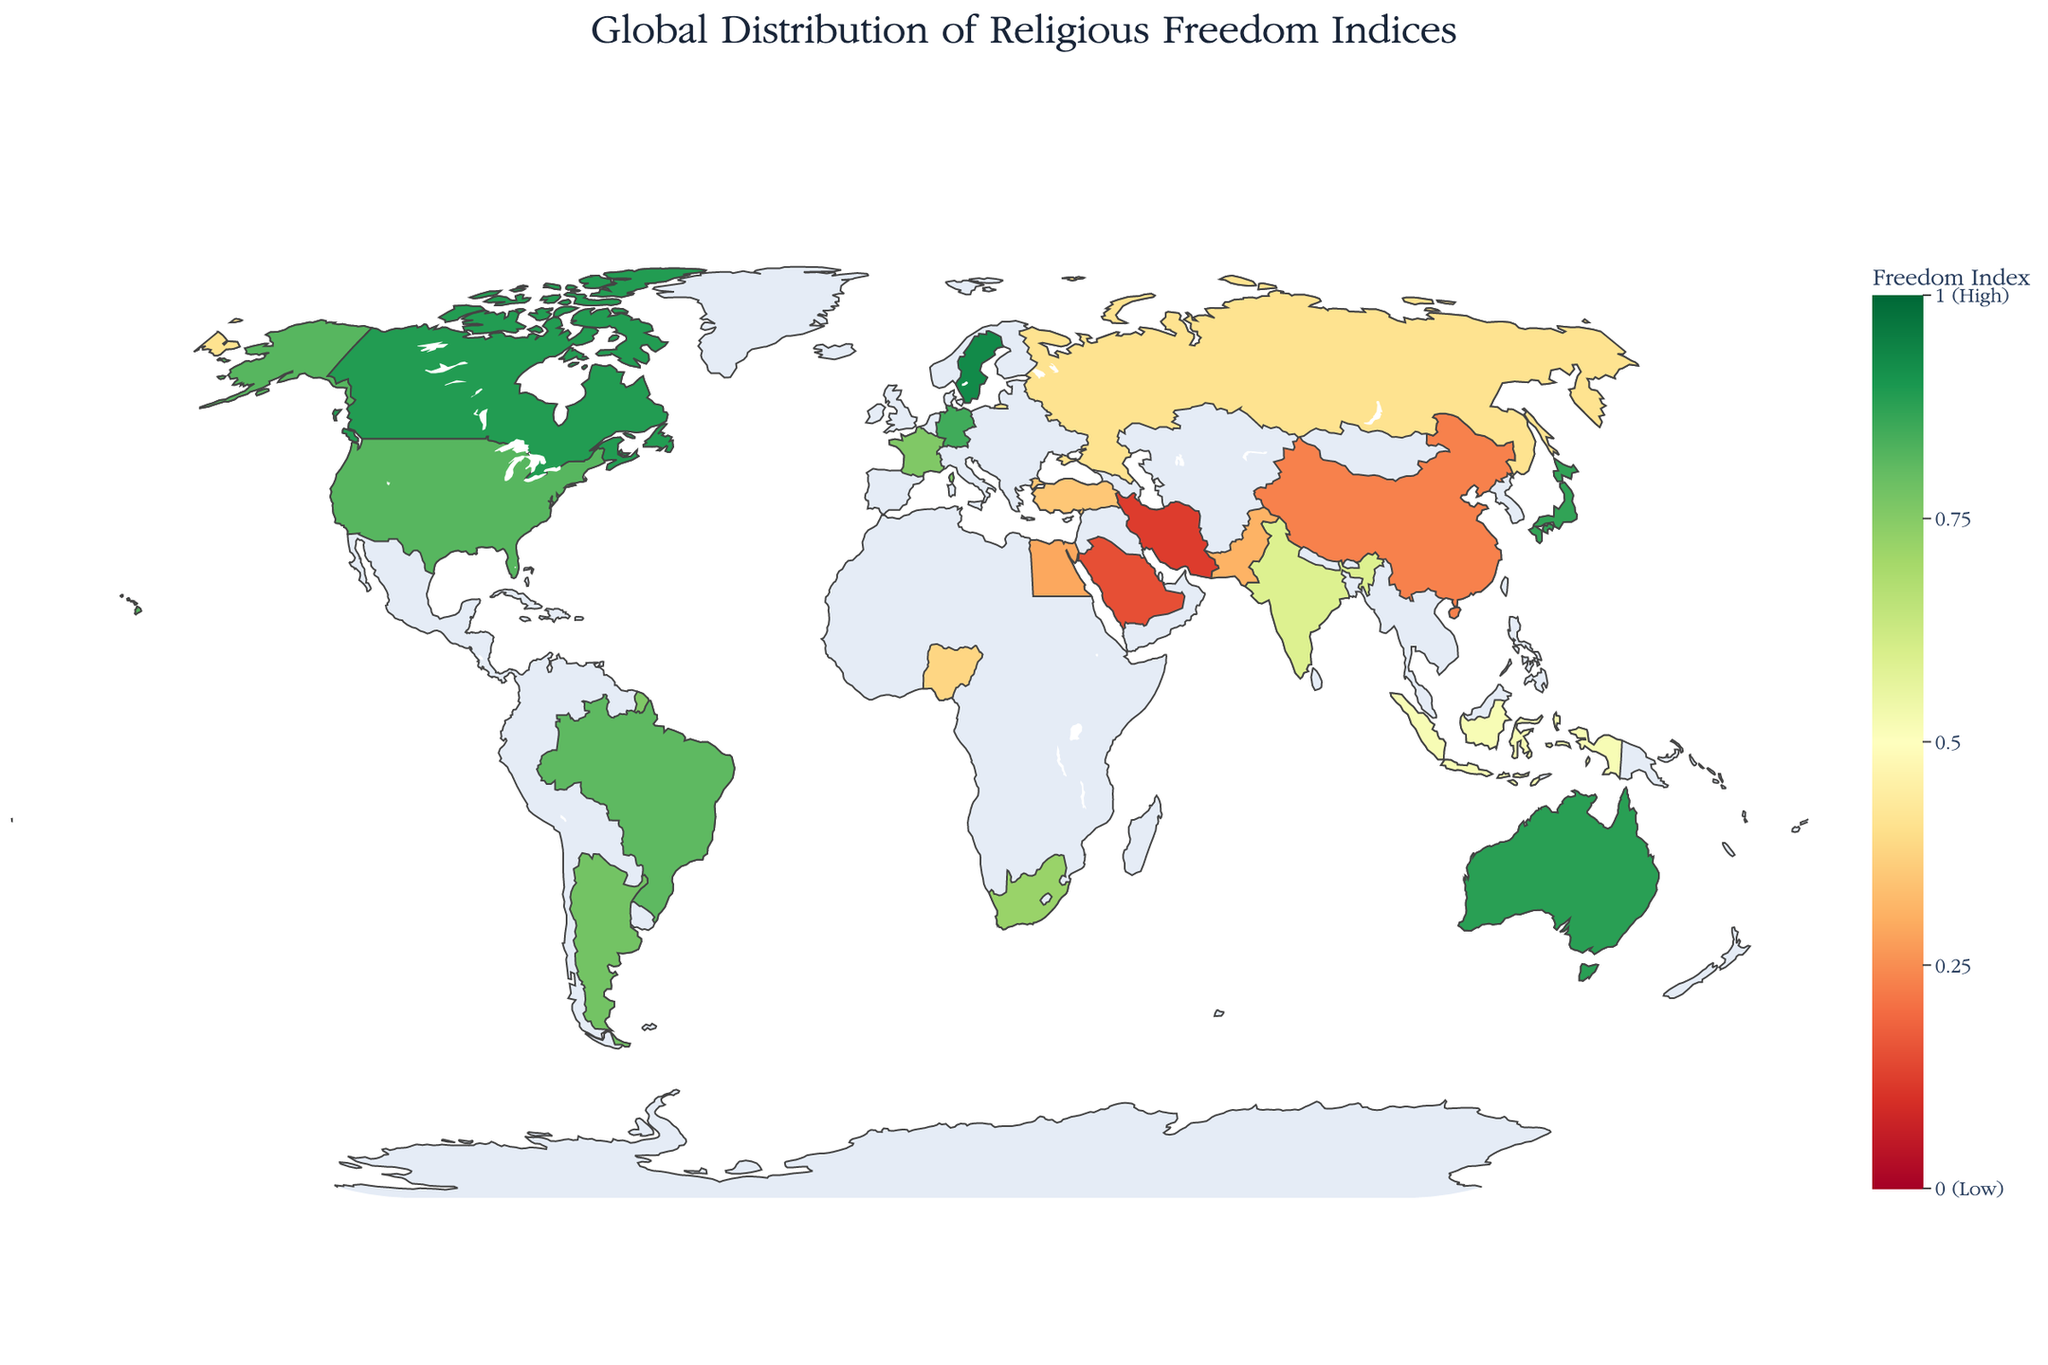How many countries are displayed on the map? Count the number of unique countries listed in the data. There are 20 countries in the data.
Answer: 20 Which country has the highest Religious Freedom Index? Looking at the data, Sweden has the highest Religious Freedom Index with a value of 0.93.
Answer: Sweden How does the Religious Freedom Index of India compare to that of China? India has a Religious Freedom Index of 0.59, whereas China has an index of 0.23. So, India's index is higher than China's.
Answer: India has a higher index What is the difference in Religious Freedom Index between the highest and lowest countries? The highest index is Sweden at 0.93, and the lowest is Iran at 0.12. The difference is 0.93 - 0.12 = 0.81.
Answer: 0.81 Which country falls in the middle in terms of the Religious Freedom Index? To find the median, list the indices in ascending order and find the middle value. With 20 values, the middle is the average of the 10th and 11th values. This corresponds to Argentina (0.78) and South Africa (0.72). The median is (0.78 + 0.72) / 2 = 0.75.
Answer: 0.75 How is the Religious Freedom Index distributed across North America? The North American countries listed are the United States (0.82) and Canada (0.89). Both have high Religious Freedom Indices.
Answer: Both the US and Canada have high indices Among Turkey, Russia, and Nigeria, which country has the lowest Religious Freedom Index? Look at the indices for Turkey (0.35), Russia (0.41), and Nigeria (0.38). Turkey has the lowest index at 0.35.
Answer: Turkey What color represents a low Religious Freedom Index on the map? The color scale is RdYlGn, where red indicates low values, yellow indicates medium values, and green indicates high values. So, red represents a low index.
Answer: Red 